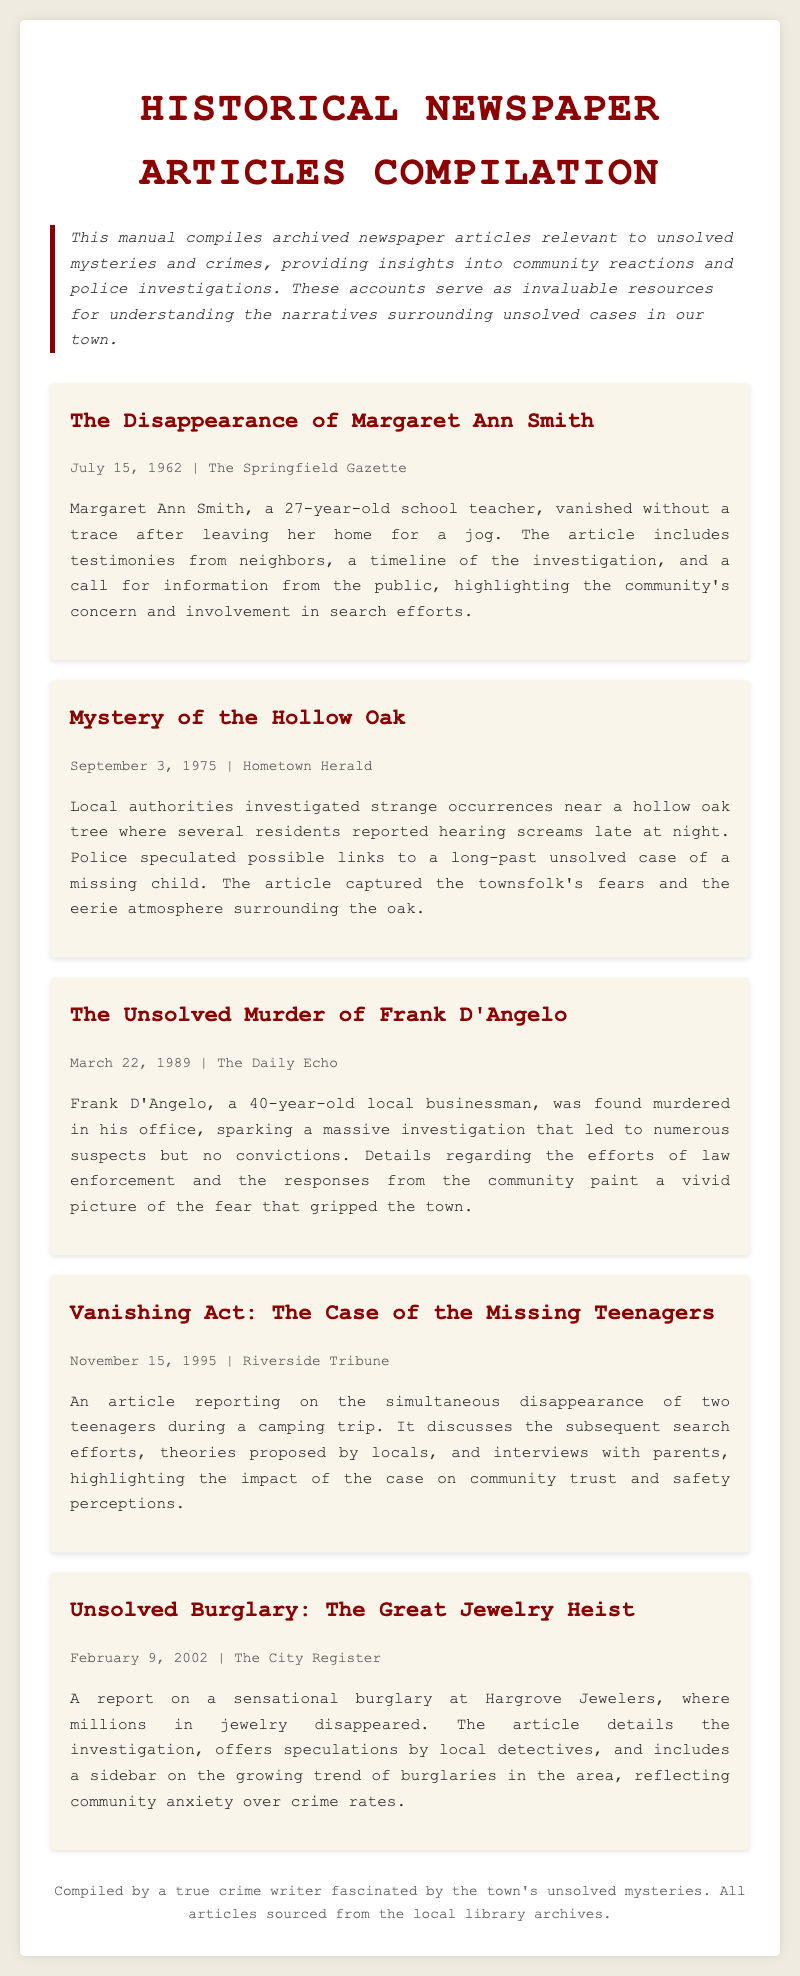What is the title of the manual? The title is mentioned at the beginning of the document, introducing the compiled articles related to unsolved mysteries.
Answer: Historical Newspaper Articles Compilation Who disappeared after going for a jog? The article states the name of the person who vanished, which is highlighted in the article summary.
Answer: Margaret Ann Smith When was the article about Frank D'Angelo published? This information is provided in the article meta section, indicating the publication date specifically.
Answer: March 22, 1989 What event sparked a massive investigation in 1989? The details regarding the investigation are included in the article summary section, pointing to a specific incident.
Answer: The Unsolved Murder of Frank D'Angelo Which newspaper reported on the Great Jewelry Heist? The source of the article is included in the article meta, indicating which newspaper published the report.
Answer: The City Register What was the community's reaction to the disappearance of the teenagers? This is described in the summary, where the impact of the case on community trust is mentioned.
Answer: Highlighted the impact on community trust and safety perceptions How many teenagers went missing during the camping trip? This detail is derived from the article regarding the incident, revealing the number of individuals involved.
Answer: Two What year was the article about the Hollow Oak published? The publication date in the article meta clearly indicates when this article was released.
Answer: September 3, 1975 What type of crime was reported in the article from February 2002? The type of incident discussed is specified in the article summary, pointing to a particular crime.
Answer: Burglary 